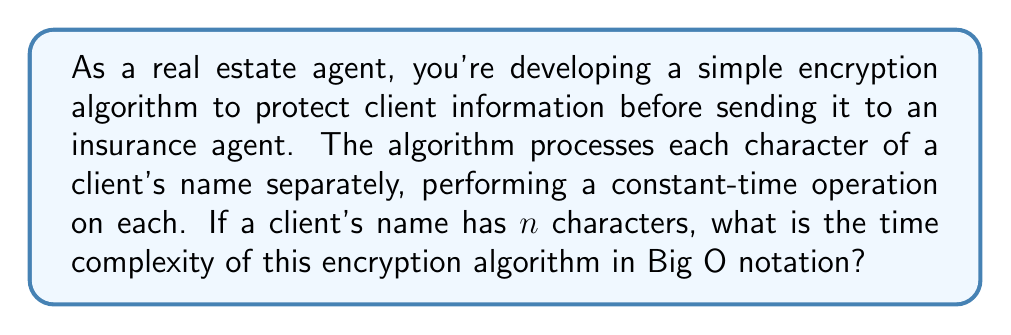Can you solve this math problem? To determine the time complexity of this encryption algorithm, let's break down the process:

1. The algorithm processes each character of the client's name individually.
2. For each character, a constant-time operation is performed.
3. The number of characters in the client's name is represented by $n$.

Now, let's analyze the time complexity:

1. Since we perform a constant-time operation on each character, let's call the time for this operation $c$.
2. We repeat this operation for each of the $n$ characters in the name.
3. The total time taken can be represented as:

   $$T(n) = c \cdot n$$

4. In Big O notation, we focus on the growth rate as $n$ increases and ignore constant factors.
5. Therefore, we can simplify $c \cdot n$ to $O(n)$.

This linear time complexity $O(n)$ indicates that the processing time increases linearly with the length of the input (client's name in this case).
Answer: $O(n)$ 